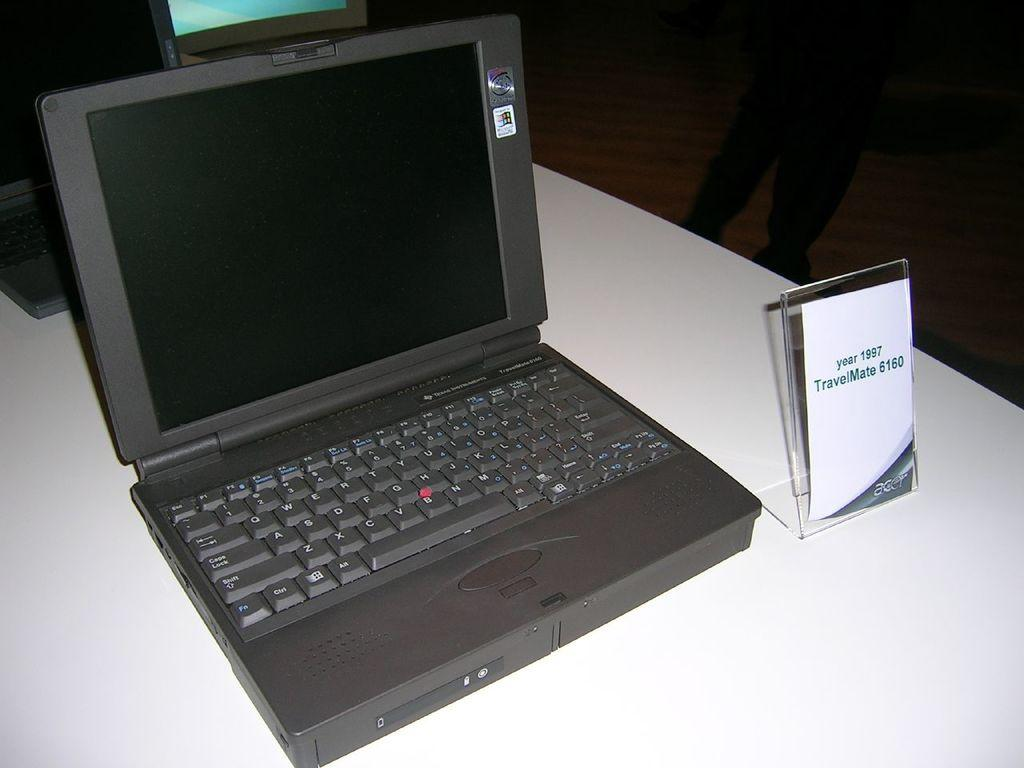<image>
Create a compact narrative representing the image presented. The old laptop shown here is from the year 1997 